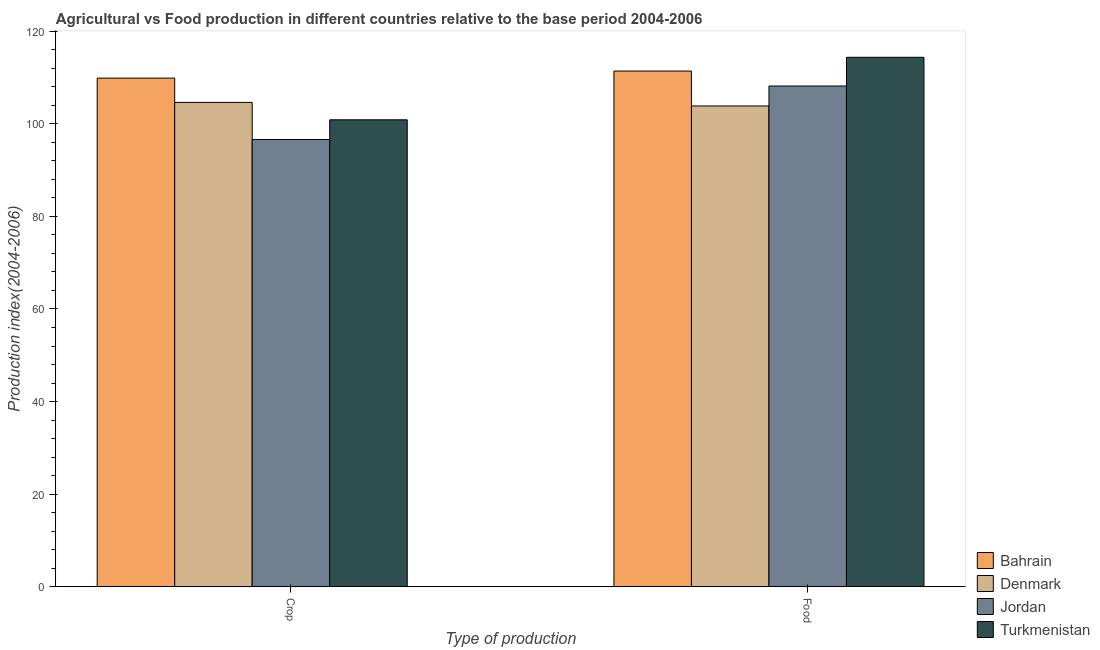Are the number of bars per tick equal to the number of legend labels?
Your answer should be very brief. Yes. Are the number of bars on each tick of the X-axis equal?
Your answer should be compact. Yes. How many bars are there on the 2nd tick from the right?
Provide a succinct answer. 4. What is the label of the 1st group of bars from the left?
Your answer should be very brief. Crop. What is the crop production index in Denmark?
Ensure brevity in your answer.  104.62. Across all countries, what is the maximum crop production index?
Give a very brief answer. 109.86. Across all countries, what is the minimum crop production index?
Ensure brevity in your answer.  96.6. In which country was the food production index maximum?
Make the answer very short. Turkmenistan. In which country was the crop production index minimum?
Your answer should be compact. Jordan. What is the total crop production index in the graph?
Give a very brief answer. 411.94. What is the difference between the food production index in Turkmenistan and that in Denmark?
Offer a very short reply. 10.51. What is the difference between the food production index in Denmark and the crop production index in Jordan?
Ensure brevity in your answer.  7.25. What is the average crop production index per country?
Offer a very short reply. 102.99. What is the difference between the food production index and crop production index in Jordan?
Provide a succinct answer. 11.56. In how many countries, is the food production index greater than 96 ?
Offer a terse response. 4. What is the ratio of the crop production index in Bahrain to that in Turkmenistan?
Provide a succinct answer. 1.09. Is the food production index in Denmark less than that in Turkmenistan?
Ensure brevity in your answer.  Yes. What does the 4th bar from the left in Crop represents?
Offer a terse response. Turkmenistan. What does the 4th bar from the right in Food represents?
Make the answer very short. Bahrain. What is the title of the graph?
Ensure brevity in your answer.  Agricultural vs Food production in different countries relative to the base period 2004-2006. Does "Kiribati" appear as one of the legend labels in the graph?
Ensure brevity in your answer.  No. What is the label or title of the X-axis?
Keep it short and to the point. Type of production. What is the label or title of the Y-axis?
Provide a succinct answer. Production index(2004-2006). What is the Production index(2004-2006) of Bahrain in Crop?
Your answer should be very brief. 109.86. What is the Production index(2004-2006) in Denmark in Crop?
Offer a very short reply. 104.62. What is the Production index(2004-2006) of Jordan in Crop?
Provide a short and direct response. 96.6. What is the Production index(2004-2006) of Turkmenistan in Crop?
Your response must be concise. 100.86. What is the Production index(2004-2006) in Bahrain in Food?
Keep it short and to the point. 111.39. What is the Production index(2004-2006) of Denmark in Food?
Ensure brevity in your answer.  103.85. What is the Production index(2004-2006) of Jordan in Food?
Make the answer very short. 108.16. What is the Production index(2004-2006) of Turkmenistan in Food?
Your response must be concise. 114.36. Across all Type of production, what is the maximum Production index(2004-2006) of Bahrain?
Provide a short and direct response. 111.39. Across all Type of production, what is the maximum Production index(2004-2006) of Denmark?
Your answer should be very brief. 104.62. Across all Type of production, what is the maximum Production index(2004-2006) in Jordan?
Provide a short and direct response. 108.16. Across all Type of production, what is the maximum Production index(2004-2006) in Turkmenistan?
Offer a very short reply. 114.36. Across all Type of production, what is the minimum Production index(2004-2006) of Bahrain?
Provide a succinct answer. 109.86. Across all Type of production, what is the minimum Production index(2004-2006) of Denmark?
Make the answer very short. 103.85. Across all Type of production, what is the minimum Production index(2004-2006) in Jordan?
Keep it short and to the point. 96.6. Across all Type of production, what is the minimum Production index(2004-2006) in Turkmenistan?
Provide a succinct answer. 100.86. What is the total Production index(2004-2006) of Bahrain in the graph?
Make the answer very short. 221.25. What is the total Production index(2004-2006) in Denmark in the graph?
Offer a terse response. 208.47. What is the total Production index(2004-2006) of Jordan in the graph?
Offer a terse response. 204.76. What is the total Production index(2004-2006) of Turkmenistan in the graph?
Give a very brief answer. 215.22. What is the difference between the Production index(2004-2006) of Bahrain in Crop and that in Food?
Make the answer very short. -1.53. What is the difference between the Production index(2004-2006) of Denmark in Crop and that in Food?
Give a very brief answer. 0.77. What is the difference between the Production index(2004-2006) in Jordan in Crop and that in Food?
Your answer should be very brief. -11.56. What is the difference between the Production index(2004-2006) of Turkmenistan in Crop and that in Food?
Your answer should be compact. -13.5. What is the difference between the Production index(2004-2006) of Bahrain in Crop and the Production index(2004-2006) of Denmark in Food?
Your response must be concise. 6.01. What is the difference between the Production index(2004-2006) of Bahrain in Crop and the Production index(2004-2006) of Jordan in Food?
Your answer should be very brief. 1.7. What is the difference between the Production index(2004-2006) in Bahrain in Crop and the Production index(2004-2006) in Turkmenistan in Food?
Keep it short and to the point. -4.5. What is the difference between the Production index(2004-2006) of Denmark in Crop and the Production index(2004-2006) of Jordan in Food?
Ensure brevity in your answer.  -3.54. What is the difference between the Production index(2004-2006) in Denmark in Crop and the Production index(2004-2006) in Turkmenistan in Food?
Offer a terse response. -9.74. What is the difference between the Production index(2004-2006) in Jordan in Crop and the Production index(2004-2006) in Turkmenistan in Food?
Offer a very short reply. -17.76. What is the average Production index(2004-2006) of Bahrain per Type of production?
Keep it short and to the point. 110.62. What is the average Production index(2004-2006) in Denmark per Type of production?
Provide a succinct answer. 104.23. What is the average Production index(2004-2006) of Jordan per Type of production?
Keep it short and to the point. 102.38. What is the average Production index(2004-2006) in Turkmenistan per Type of production?
Make the answer very short. 107.61. What is the difference between the Production index(2004-2006) of Bahrain and Production index(2004-2006) of Denmark in Crop?
Keep it short and to the point. 5.24. What is the difference between the Production index(2004-2006) in Bahrain and Production index(2004-2006) in Jordan in Crop?
Provide a short and direct response. 13.26. What is the difference between the Production index(2004-2006) in Denmark and Production index(2004-2006) in Jordan in Crop?
Your answer should be compact. 8.02. What is the difference between the Production index(2004-2006) in Denmark and Production index(2004-2006) in Turkmenistan in Crop?
Provide a short and direct response. 3.76. What is the difference between the Production index(2004-2006) of Jordan and Production index(2004-2006) of Turkmenistan in Crop?
Ensure brevity in your answer.  -4.26. What is the difference between the Production index(2004-2006) in Bahrain and Production index(2004-2006) in Denmark in Food?
Ensure brevity in your answer.  7.54. What is the difference between the Production index(2004-2006) in Bahrain and Production index(2004-2006) in Jordan in Food?
Your answer should be very brief. 3.23. What is the difference between the Production index(2004-2006) in Bahrain and Production index(2004-2006) in Turkmenistan in Food?
Give a very brief answer. -2.97. What is the difference between the Production index(2004-2006) of Denmark and Production index(2004-2006) of Jordan in Food?
Provide a succinct answer. -4.31. What is the difference between the Production index(2004-2006) in Denmark and Production index(2004-2006) in Turkmenistan in Food?
Provide a short and direct response. -10.51. What is the difference between the Production index(2004-2006) of Jordan and Production index(2004-2006) of Turkmenistan in Food?
Provide a succinct answer. -6.2. What is the ratio of the Production index(2004-2006) in Bahrain in Crop to that in Food?
Offer a terse response. 0.99. What is the ratio of the Production index(2004-2006) in Denmark in Crop to that in Food?
Make the answer very short. 1.01. What is the ratio of the Production index(2004-2006) of Jordan in Crop to that in Food?
Provide a short and direct response. 0.89. What is the ratio of the Production index(2004-2006) in Turkmenistan in Crop to that in Food?
Make the answer very short. 0.88. What is the difference between the highest and the second highest Production index(2004-2006) in Bahrain?
Your response must be concise. 1.53. What is the difference between the highest and the second highest Production index(2004-2006) of Denmark?
Offer a very short reply. 0.77. What is the difference between the highest and the second highest Production index(2004-2006) of Jordan?
Provide a succinct answer. 11.56. What is the difference between the highest and the lowest Production index(2004-2006) of Bahrain?
Provide a succinct answer. 1.53. What is the difference between the highest and the lowest Production index(2004-2006) in Denmark?
Offer a very short reply. 0.77. What is the difference between the highest and the lowest Production index(2004-2006) in Jordan?
Provide a succinct answer. 11.56. 